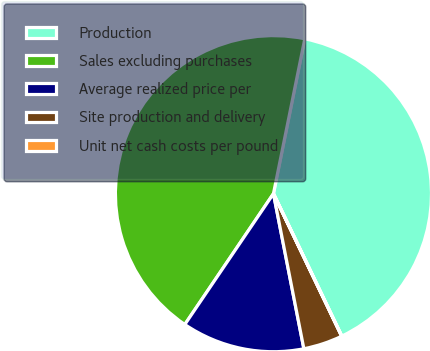<chart> <loc_0><loc_0><loc_500><loc_500><pie_chart><fcel>Production<fcel>Sales excluding purchases<fcel>Average realized price per<fcel>Site production and delivery<fcel>Unit net cash costs per pound<nl><fcel>39.7%<fcel>43.7%<fcel>12.56%<fcel>4.02%<fcel>0.02%<nl></chart> 